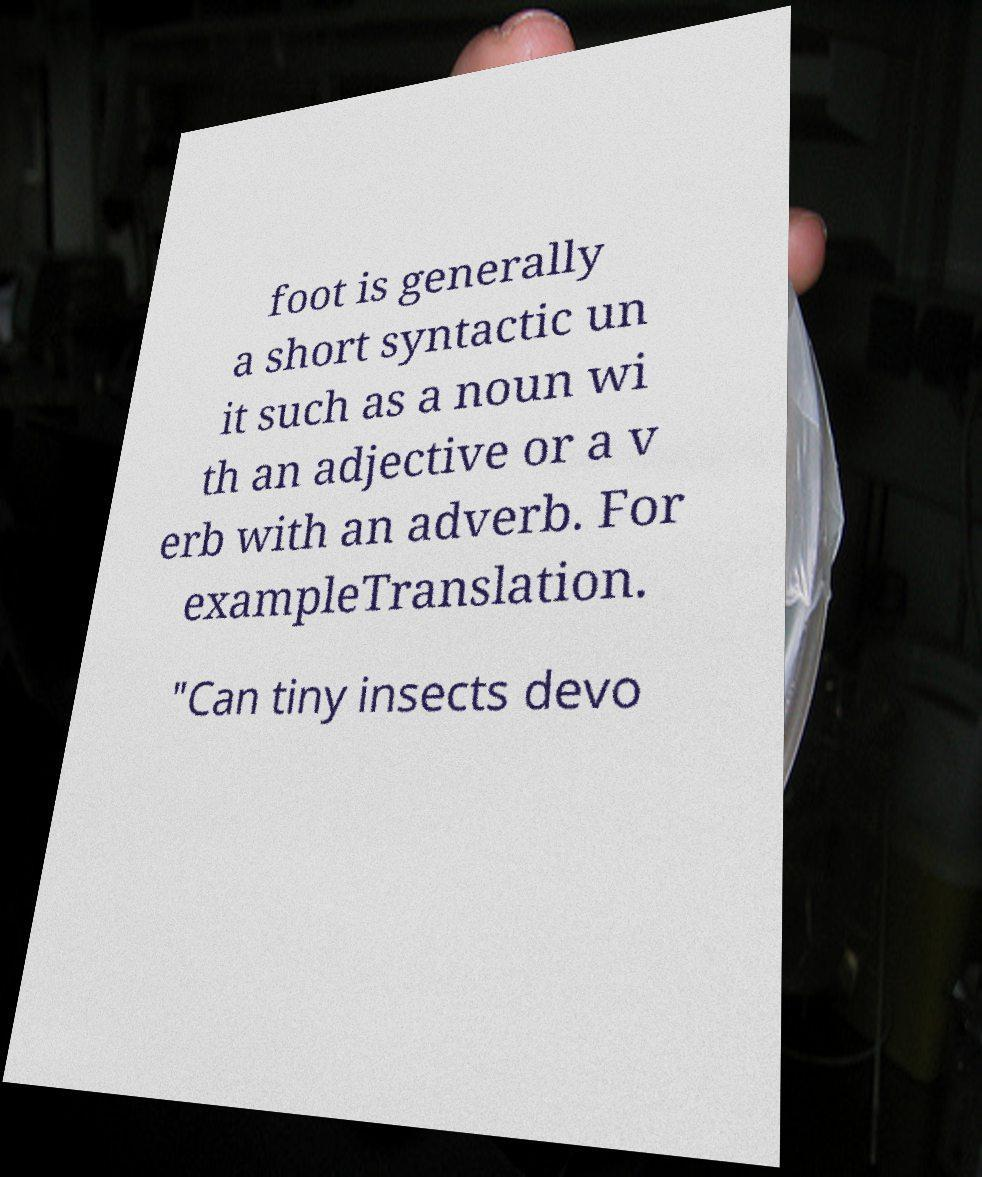What messages or text are displayed in this image? I need them in a readable, typed format. foot is generally a short syntactic un it such as a noun wi th an adjective or a v erb with an adverb. For exampleTranslation. "Can tiny insects devo 